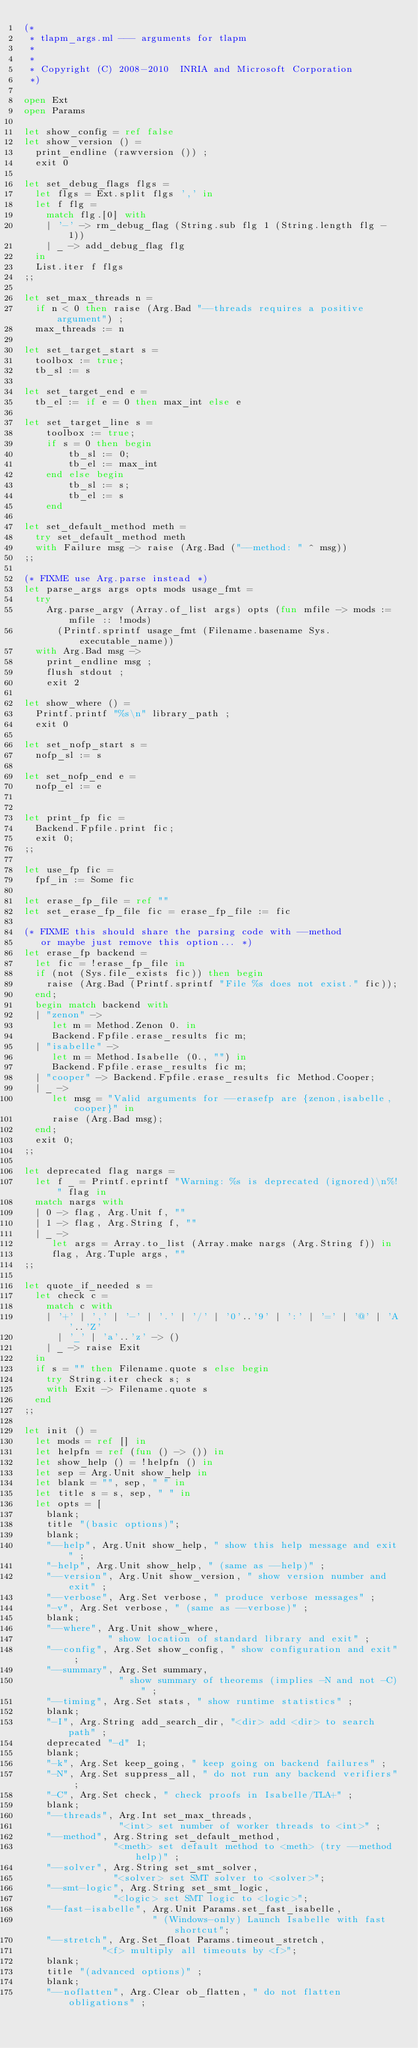<code> <loc_0><loc_0><loc_500><loc_500><_OCaml_>(*
 * tlapm_args.ml --- arguments for tlapm
 *
 *
 * Copyright (C) 2008-2010  INRIA and Microsoft Corporation
 *)

open Ext
open Params

let show_config = ref false
let show_version () =
  print_endline (rawversion ()) ;
  exit 0

let set_debug_flags flgs =
  let flgs = Ext.split flgs ',' in
  let f flg =
    match flg.[0] with
    | '-' -> rm_debug_flag (String.sub flg 1 (String.length flg - 1))
    | _ -> add_debug_flag flg
  in
  List.iter f flgs
;;

let set_max_threads n =
  if n < 0 then raise (Arg.Bad "--threads requires a positive argument") ;
  max_threads := n

let set_target_start s =
  toolbox := true;
  tb_sl := s

let set_target_end e =
  tb_el := if e = 0 then max_int else e

let set_target_line s =
    toolbox := true;
    if s = 0 then begin
        tb_sl := 0;
        tb_el := max_int
    end else begin
        tb_sl := s;
        tb_el := s
    end

let set_default_method meth =
  try set_default_method meth
  with Failure msg -> raise (Arg.Bad ("--method: " ^ msg))
;;

(* FIXME use Arg.parse instead *)
let parse_args args opts mods usage_fmt =
  try
    Arg.parse_argv (Array.of_list args) opts (fun mfile -> mods := mfile :: !mods)
      (Printf.sprintf usage_fmt (Filename.basename Sys.executable_name))
  with Arg.Bad msg ->
    print_endline msg ;
    flush stdout ;
    exit 2

let show_where () =
  Printf.printf "%s\n" library_path ;
  exit 0

let set_nofp_start s =
  nofp_sl := s

let set_nofp_end e =
  nofp_el := e


let print_fp fic =
  Backend.Fpfile.print fic;
  exit 0;
;;

let use_fp fic =
  fpf_in := Some fic

let erase_fp_file = ref ""
let set_erase_fp_file fic = erase_fp_file := fic

(* FIXME this should share the parsing code with --method
   or maybe just remove this option... *)
let erase_fp backend =
  let fic = !erase_fp_file in
  if (not (Sys.file_exists fic)) then begin
    raise (Arg.Bad (Printf.sprintf "File %s does not exist." fic));
  end;
  begin match backend with
  | "zenon" ->
     let m = Method.Zenon 0. in
     Backend.Fpfile.erase_results fic m;
  | "isabelle" ->
     let m = Method.Isabelle (0., "") in
     Backend.Fpfile.erase_results fic m;
  | "cooper" -> Backend.Fpfile.erase_results fic Method.Cooper;
  | _ ->
     let msg = "Valid arguments for --erasefp are {zenon,isabelle,cooper}" in
     raise (Arg.Bad msg);
  end;
  exit 0;
;;

let deprecated flag nargs =
  let f _ = Printf.eprintf "Warning: %s is deprecated (ignored)\n%!" flag in
  match nargs with
  | 0 -> flag, Arg.Unit f, ""
  | 1 -> flag, Arg.String f, ""
  | _ ->
     let args = Array.to_list (Array.make nargs (Arg.String f)) in
     flag, Arg.Tuple args, ""
;;

let quote_if_needed s =
  let check c =
    match c with
    | '+' | ',' | '-' | '.' | '/' | '0'..'9' | ':' | '=' | '@' | 'A'..'Z'
      | '_' | 'a'..'z' -> ()
    | _ -> raise Exit
  in
  if s = "" then Filename.quote s else begin
    try String.iter check s; s
    with Exit -> Filename.quote s
  end
;;

let init () =
  let mods = ref [] in
  let helpfn = ref (fun () -> ()) in
  let show_help () = !helpfn () in
  let sep = Arg.Unit show_help in
  let blank = "", sep, " " in
  let title s = s, sep, " " in
  let opts = [
    blank;
    title "(basic options)";
    blank;
    "--help", Arg.Unit show_help, " show this help message and exit" ;
    "-help", Arg.Unit show_help, " (same as --help)" ;
    "--version", Arg.Unit show_version, " show version number and exit" ;
    "--verbose", Arg.Set verbose, " produce verbose messages" ;
    "-v", Arg.Set verbose, " (same as --verbose)" ;
    blank;
    "--where", Arg.Unit show_where,
               " show location of standard library and exit" ;
    "--config", Arg.Set show_config, " show configuration and exit" ;
    "--summary", Arg.Set summary,
                 " show summary of theorems (implies -N and not -C)" ;
    "--timing", Arg.Set stats, " show runtime statistics" ;
    blank;
    "-I", Arg.String add_search_dir, "<dir> add <dir> to search path" ;
    deprecated "-d" 1;
    blank;
    "-k", Arg.Set keep_going, " keep going on backend failures" ;
    "-N", Arg.Set suppress_all, " do not run any backend verifiers" ;
    "-C", Arg.Set check, " check proofs in Isabelle/TLA+" ;
    blank;
    "--threads", Arg.Int set_max_threads,
                 "<int> set number of worker threads to <int>" ;
    "--method", Arg.String set_default_method,
                "<meth> set default method to <meth> (try --method help)" ;
    "--solver", Arg.String set_smt_solver,
                "<solver> set SMT solver to <solver>";
    "--smt-logic", Arg.String set_smt_logic,
                "<logic> set SMT logic to <logic>";
    "--fast-isabelle", Arg.Unit Params.set_fast_isabelle,
                       " (Windows-only) Launch Isabelle with fast shortcut";
    "--stretch", Arg.Set_float Params.timeout_stretch,
              "<f> multiply all timeouts by <f>";
    blank;
    title "(advanced options)" ;
    blank;
    "--noflatten", Arg.Clear ob_flatten, " do not flatten obligations" ;</code> 